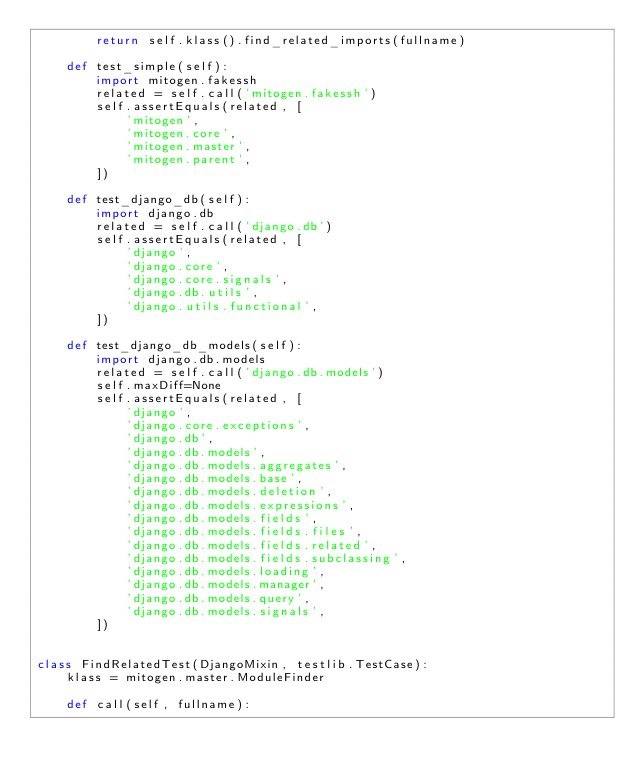<code> <loc_0><loc_0><loc_500><loc_500><_Python_>        return self.klass().find_related_imports(fullname)

    def test_simple(self):
        import mitogen.fakessh
        related = self.call('mitogen.fakessh')
        self.assertEquals(related, [
            'mitogen',
            'mitogen.core',
            'mitogen.master',
            'mitogen.parent',
        ])

    def test_django_db(self):
        import django.db
        related = self.call('django.db')
        self.assertEquals(related, [
            'django',
            'django.core',
            'django.core.signals',
            'django.db.utils',
            'django.utils.functional',
        ])

    def test_django_db_models(self):
        import django.db.models
        related = self.call('django.db.models')
        self.maxDiff=None
        self.assertEquals(related, [
            'django',
            'django.core.exceptions',
            'django.db',
            'django.db.models',
            'django.db.models.aggregates',
            'django.db.models.base',
            'django.db.models.deletion',
            'django.db.models.expressions',
            'django.db.models.fields',
            'django.db.models.fields.files',
            'django.db.models.fields.related',
            'django.db.models.fields.subclassing',
            'django.db.models.loading',
            'django.db.models.manager',
            'django.db.models.query',
            'django.db.models.signals',
        ])


class FindRelatedTest(DjangoMixin, testlib.TestCase):
    klass = mitogen.master.ModuleFinder

    def call(self, fullname):</code> 